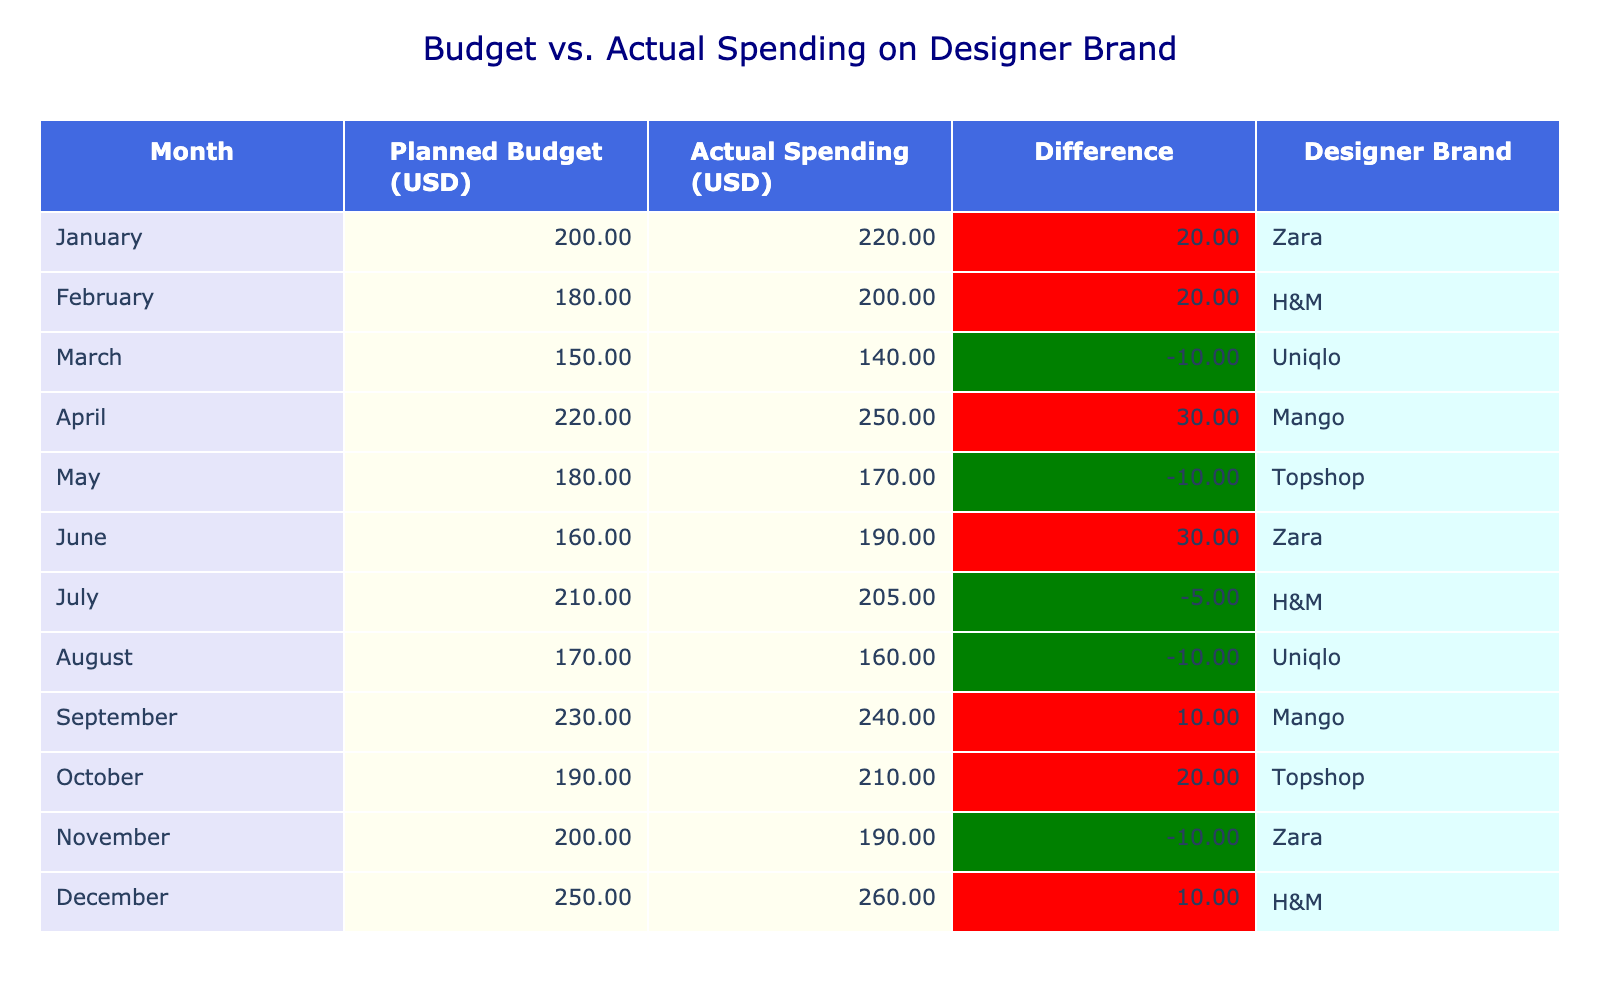What is the actual spending for February? The actual spending for February is listed in the table under the column "Actual Spending (USD)" for that month, which shows the value as 200.
Answer: 200 What was the difference in spending for March? The difference for March can be calculated by taking the actual spending (140) and subtracting the planned budget (150). This results in a difference of -10.
Answer: -10 Which month had the highest planned budget? The highest planned budget is found in December, where the planned budget is 250.
Answer: 250 Was the actual spending for April higher or lower than the planned budget? For April, the planned budget is 220, and the actual spending is 250. Since 250 is greater than 220, the actual spending is higher.
Answer: Higher What is the total actual spending for the months of July to December? To find the total for July to December, we sum the actual spending amounts: 205 (July) + 160 (August) + 240 (September) + 210 (October) + 190 (November) + 260 (December) = 1265.
Answer: 1265 Which designer brand had the largest overspend in a single month, and by how much? To identify the largest overspend, we need to calculate the differences for each month and find the maximum. The overspend is highest in April, with an overspend of 30 (250 - 220).
Answer: Mango, 30 What was the average planned budget over the entire year? The planned budgets for all months are: 200, 180, 150, 220, 180, 160, 210, 170, 230, 190, 200, 250. Summing these gives 2,470. Dividing by the number of months (12) results in an average planned budget of approximately 205.83.
Answer: 205.83 Did any month have actual spending equal to the planned budget? By examining the table, we see that in May, the actual spending (170) matched the planned budget (170). Therefore, yes, one month did have equal spending.
Answer: Yes What is the total difference between planned budget and actual spending for the year? To find the total difference, we sum the differences calculated for each month. When we add all the differences, we find a total difference of 50, meaning the overall actual spending exceeded the planned budget by 50.
Answer: 50 